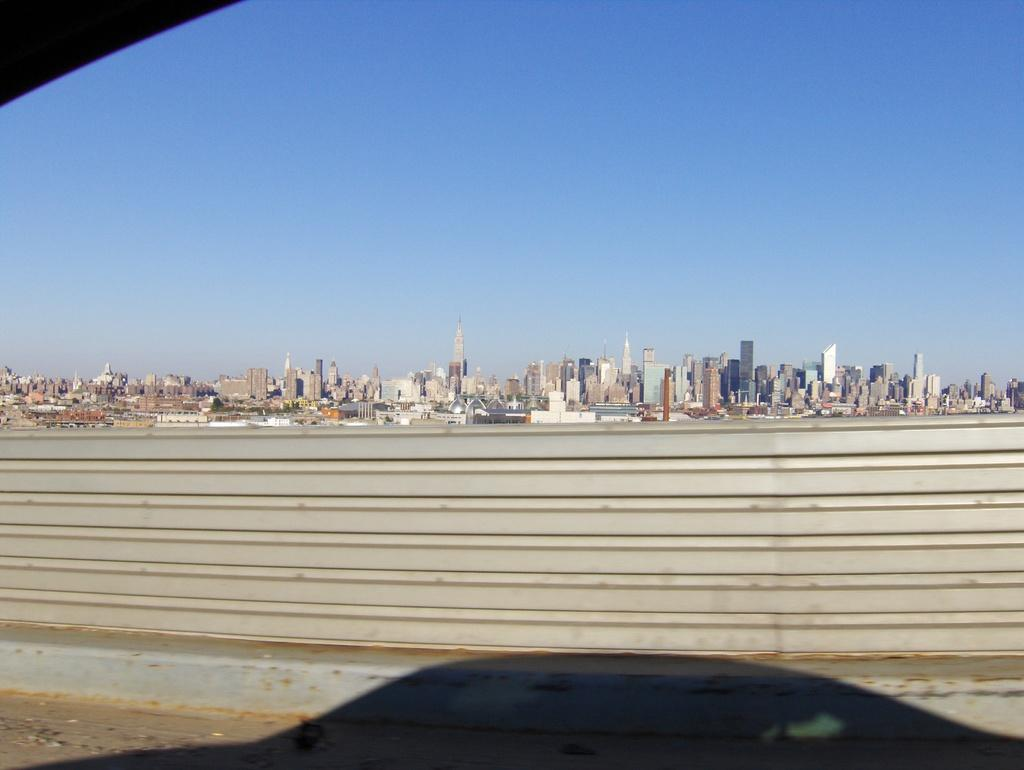What is located in the center of the image? There is a fence in the center of the image. What can be seen in the background of the image? There are buildings in the background of the image. What is visible at the top of the image? The sky is visible at the top of the image. How many dolls are sitting on the line in the image? There are no dolls or lines present in the image. 